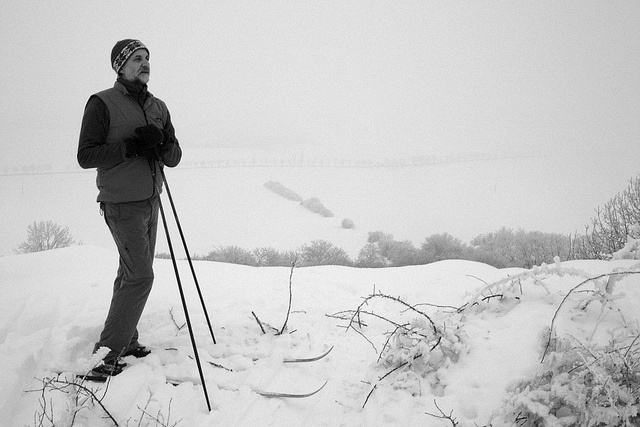Describe the objects in this image and their specific colors. I can see people in lightgray, black, gray, and darkgray tones and skis in lightgray, darkgray, gray, and black tones in this image. 